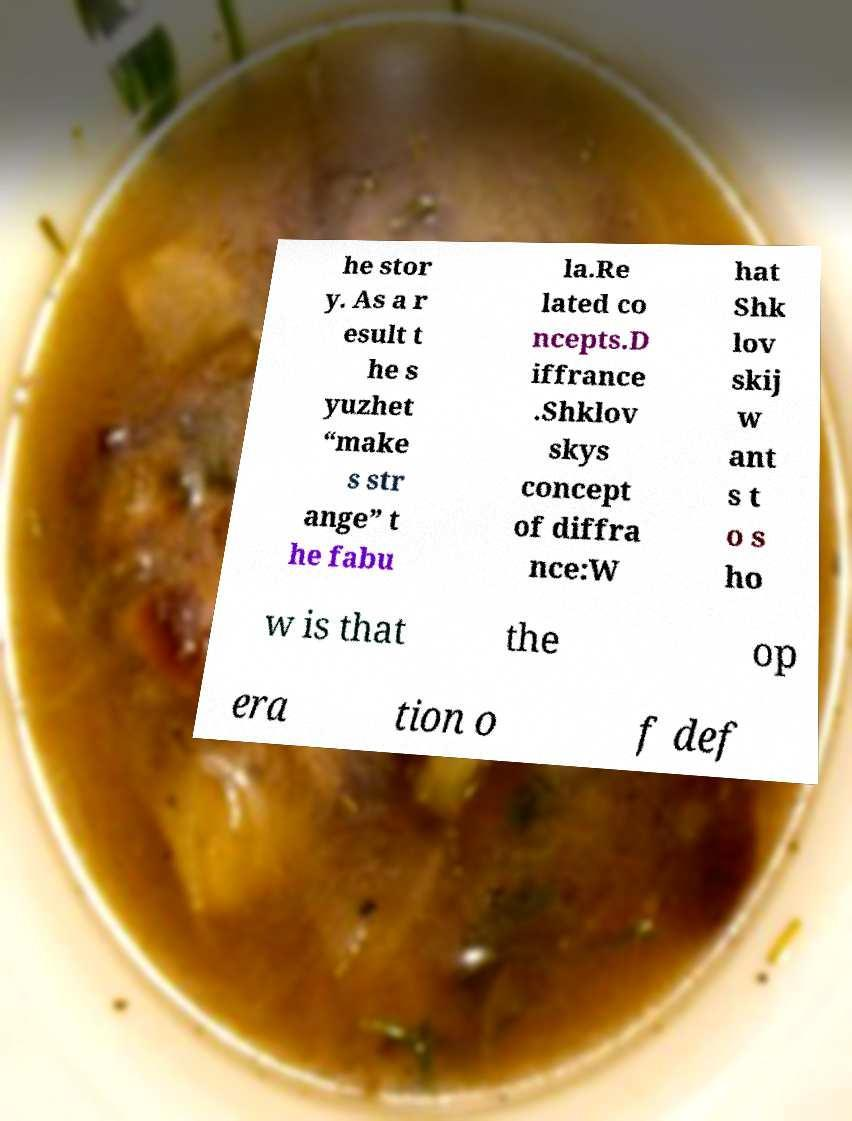Please identify and transcribe the text found in this image. he stor y. As a r esult t he s yuzhet “make s str ange” t he fabu la.Re lated co ncepts.D iffrance .Shklov skys concept of diffra nce:W hat Shk lov skij w ant s t o s ho w is that the op era tion o f def 